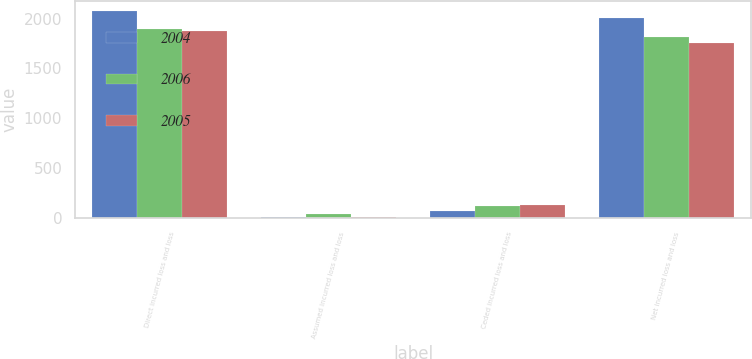Convert chart to OTSL. <chart><loc_0><loc_0><loc_500><loc_500><stacked_bar_chart><ecel><fcel>Direct incurred loss and loss<fcel>Assumed incurred loss and loss<fcel>Ceded incurred loss and loss<fcel>Net incurred loss and loss<nl><fcel>2004<fcel>2072<fcel>13<fcel>77<fcel>2008<nl><fcel>2006<fcel>1898<fcel>40<fcel>126<fcel>1812<nl><fcel>2005<fcel>1870<fcel>17<fcel>134<fcel>1753<nl></chart> 